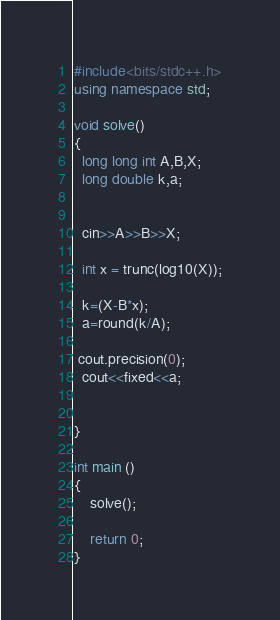<code> <loc_0><loc_0><loc_500><loc_500><_C++_>#include<bits/stdc++.h>
using namespace std;

void solve()
{
  long long int A,B,X;
  long double k,a;


  cin>>A>>B>>X;

  int x = trunc(log10(X));

  k=(X-B*x);
  a=round(k/A);

 cout.precision(0);
  cout<<fixed<<a;


}

int main ()
{
    solve();

    return 0;
}
</code> 